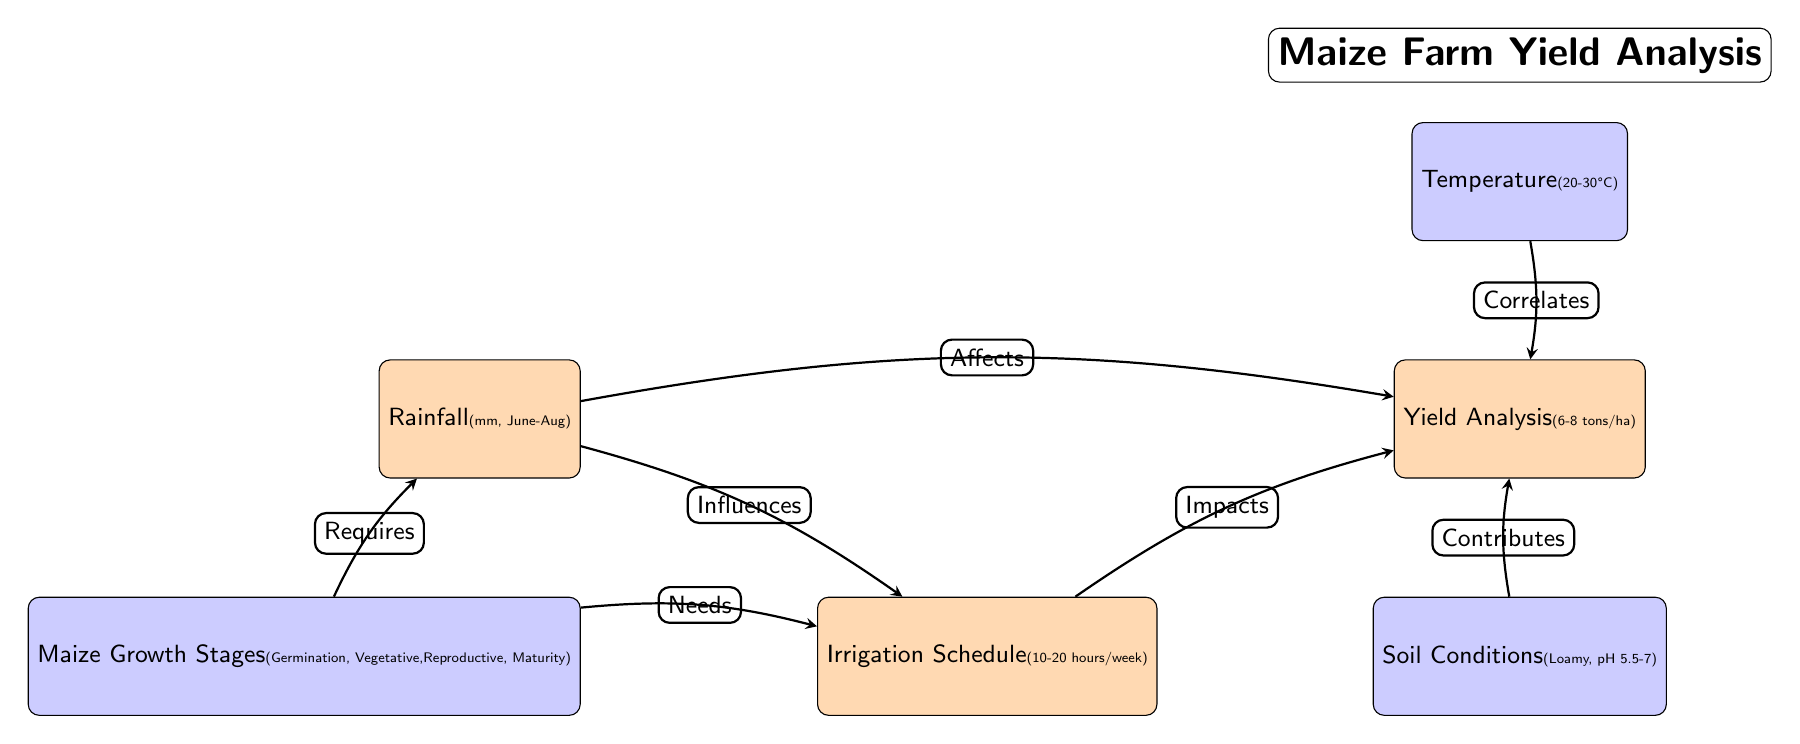What is the rainfall measured in? The diagram specifies rainfall measurement as millimeters (mm) for the months of June to August. This is evident from the label on the main node labeled "Rainfall".
Answer: mm How many main nodes are in the diagram? Upon counting the nodes that have the "main node" style, there are three main nodes in the diagram: Rainfall, Irrigation Schedule, and Yield Analysis.
Answer: 3 What does rainfall influence? The diagram shows an edge labeled "Influences" that connects the Rainfall node to the Irrigation Schedule node, indicating that rainfall influences irrigation.
Answer: Irrigation Schedule What temperature range is indicated? The temperature node specifies a range of 20 to 30 degrees Celsius, which is stated clearly on the node labeled "Temperature".
Answer: 20-30°C What are the maize growth stages listed? The diagram indicates that maize growth stages include Germination, Vegetative, Reproductive, and Maturity. These are found within the node labeled "Maize Growth Stages".
Answer: Germination, Vegetative, Reproductive, Maturity What impacts the yield according to the diagram? The diagram indicates that both irrigation and rainfall impact the yield, as shown by the edges labeled "Impacts" and "Affects". Therefore, combining these two aspects concludes that yield is impacted by both.
Answer: Irrigation and Rainfall What is required for maize growth? The diagram states that maize growth requires rainfall and needs irrigation, as shown by the edges labeled "Requires" and "Needs". This indicates the importance of both rainfall and irrigation for maize growth.
Answer: Rainfall and Irrigation 